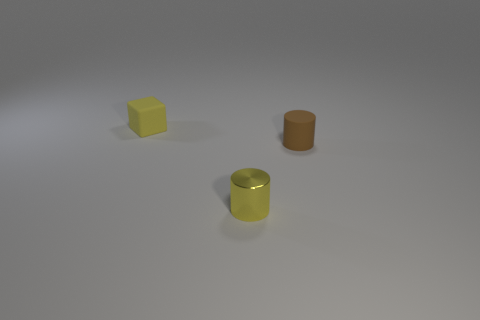There is a small yellow thing in front of the block to the left of the matte cylinder; are there any yellow things to the left of it?
Provide a succinct answer. Yes. Do the matte thing that is right of the small yellow shiny cylinder and the yellow metallic object have the same shape?
Your response must be concise. Yes. Are there more small rubber cylinders in front of the small yellow shiny object than big blue shiny cubes?
Ensure brevity in your answer.  No. There is a tiny cylinder that is on the right side of the small shiny cylinder; does it have the same color as the rubber cube?
Offer a very short reply. No. Are there any other things that have the same color as the shiny object?
Provide a succinct answer. Yes. What color is the rubber thing that is in front of the small rubber object that is on the left side of the tiny yellow object that is in front of the yellow rubber cube?
Provide a succinct answer. Brown. Does the yellow cylinder have the same size as the brown cylinder?
Offer a terse response. Yes. How many yellow things are the same size as the yellow rubber cube?
Your answer should be compact. 1. What is the shape of the tiny object that is the same color as the block?
Give a very brief answer. Cylinder. Is the small cylinder behind the shiny thing made of the same material as the tiny object that is to the left of the yellow shiny cylinder?
Your answer should be very brief. Yes. 